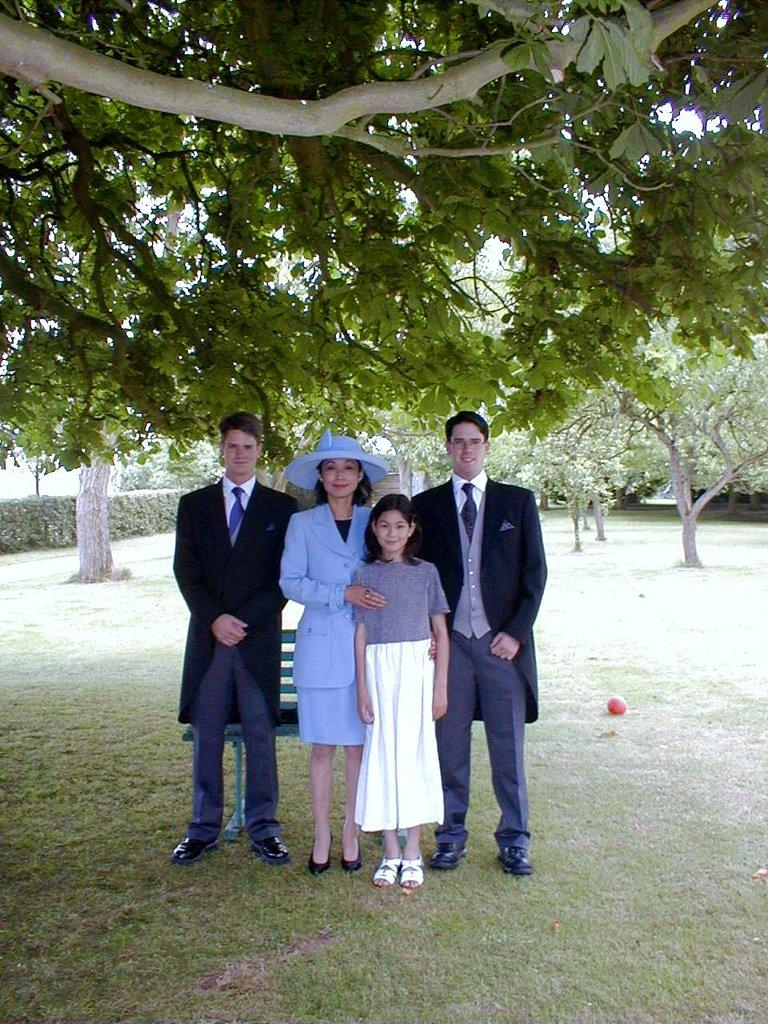How many people are present in the image? There are four people standing on the ground in the image. What type of seating is visible in the image? There is a bench in the image. What object is on the ground near the people? There is a ball on the ground. What type of vegetation can be seen in the image? There are trees, bushes, and plants in the image. What is the ground covered with? There is grass on the ground. What type of wire can be seen connecting the hill to the yard in the image? There is no wire or hill present in the image; it features four people, a bench, a ball, trees, bushes, plants, and grass. 